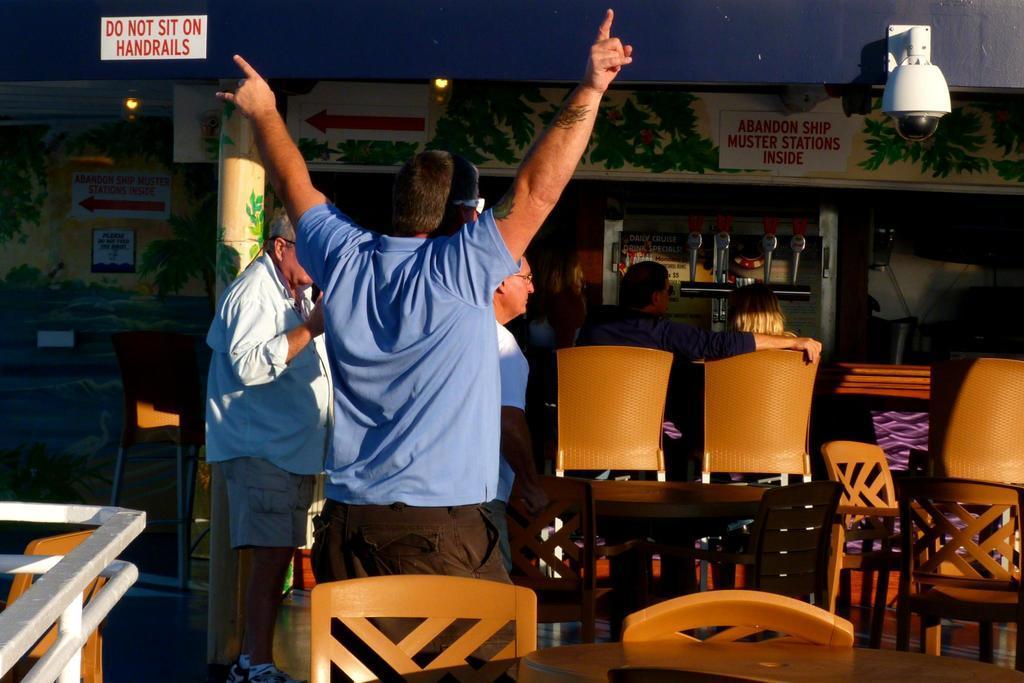Please provide a concise description of this image. In this image,There are some chairs which are in yellow color, In the left side there is a man standing and he is raising his hands in the background there are some people sitting on the chairs, In the right side top there is a camera which is in white color, There is a sky in blue color. 